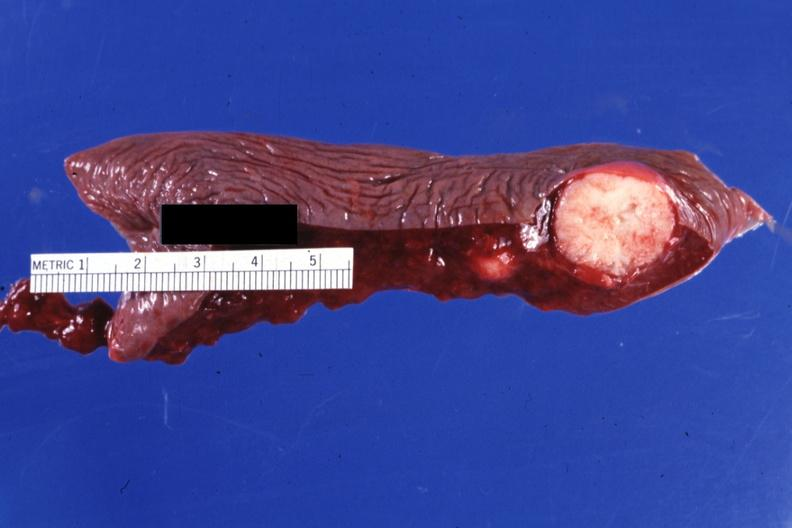where is this part in?
Answer the question using a single word or phrase. Spleen 